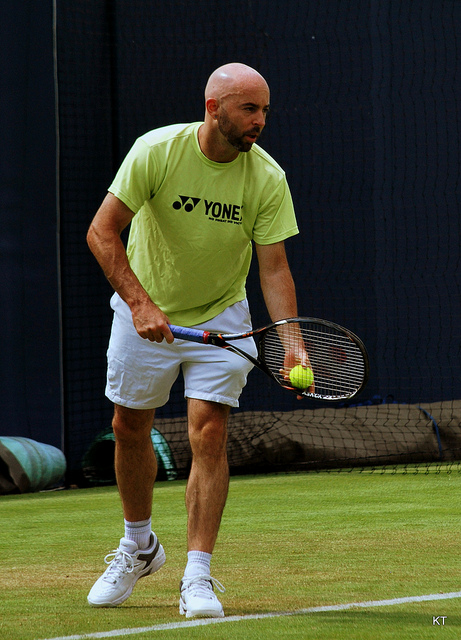<image>What tennis player is this? I don't know which tennis player this is. It could be Andre Agassi or someone else. What tennis player is this? I don't know what tennis player is in the image. It can be Andre Agassi or someone else. 